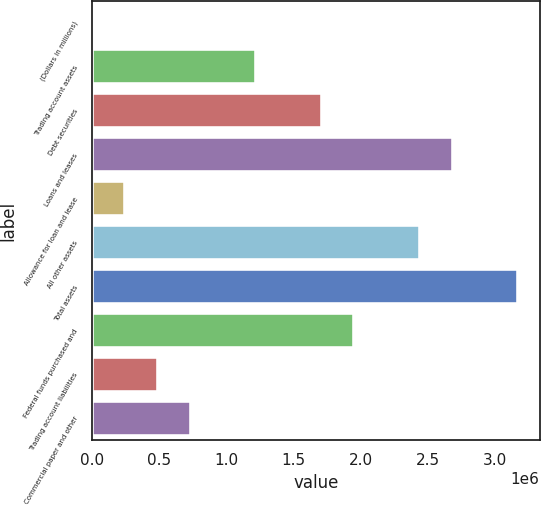<chart> <loc_0><loc_0><loc_500><loc_500><bar_chart><fcel>(Dollars in millions)<fcel>Trading account assets<fcel>Debt securities<fcel>Loans and leases<fcel>Allowance for loan and lease<fcel>All other assets<fcel>Total assets<fcel>Federal funds purchased and<fcel>Trading account liabilities<fcel>Commercial paper and other<nl><fcel>2009<fcel>1.22254e+06<fcel>1.71075e+06<fcel>2.68717e+06<fcel>246115<fcel>2.44307e+06<fcel>3.17539e+06<fcel>1.95486e+06<fcel>490221<fcel>734327<nl></chart> 